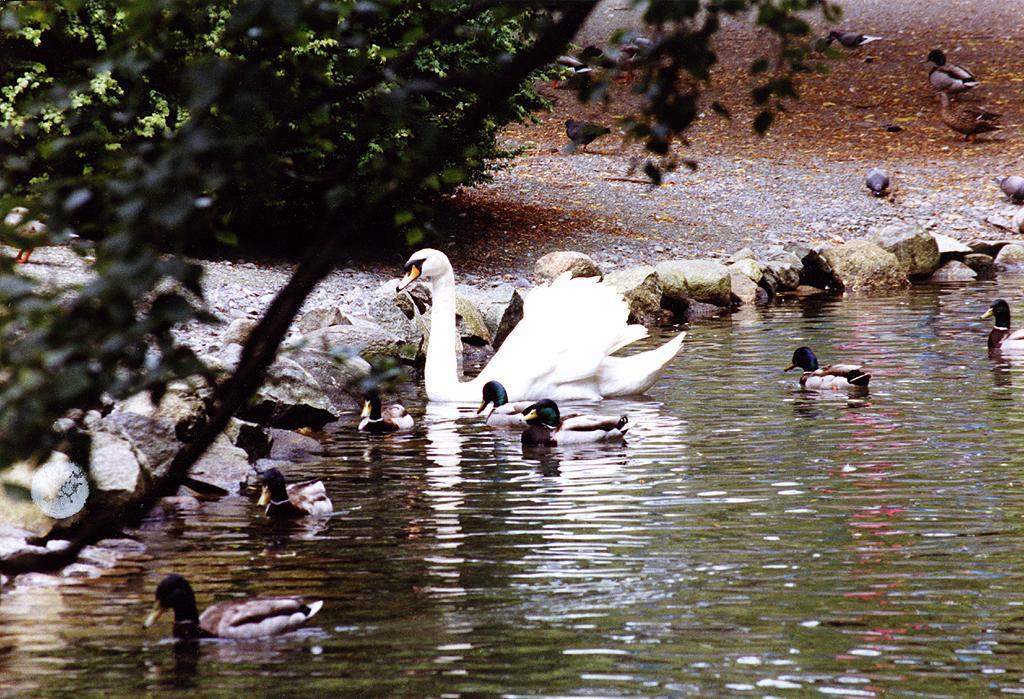In one or two sentences, can you explain what this image depicts? In This image there is a lake on the bottom of this image and there are some ducks on it. There is a tree on the left side of this image and there are some birds on the top right corner of this image and there are some stones in middle of this image. 